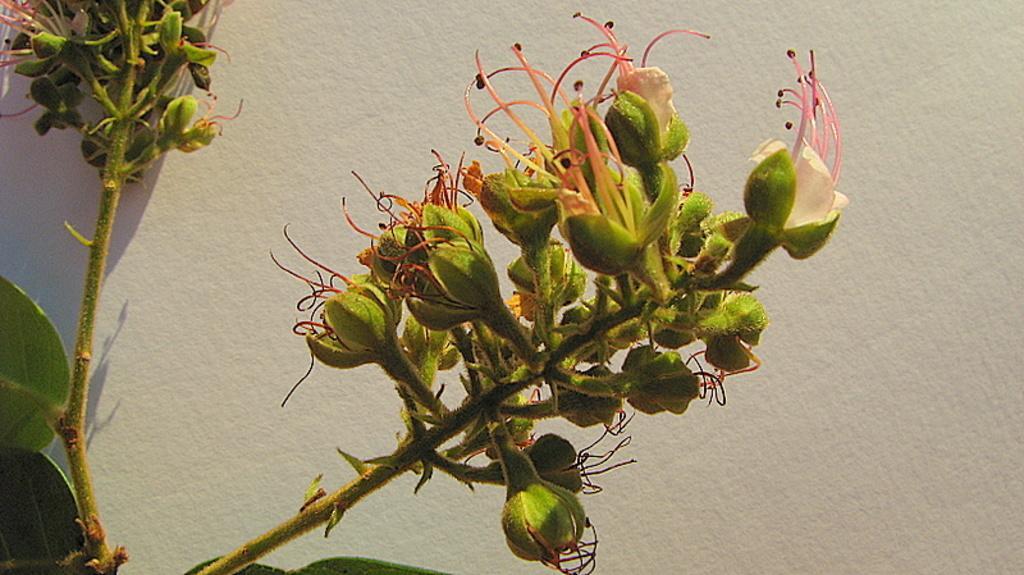Please provide a concise description of this image. In the center of the image we can see flowers to the wall. In the background there is wall. 